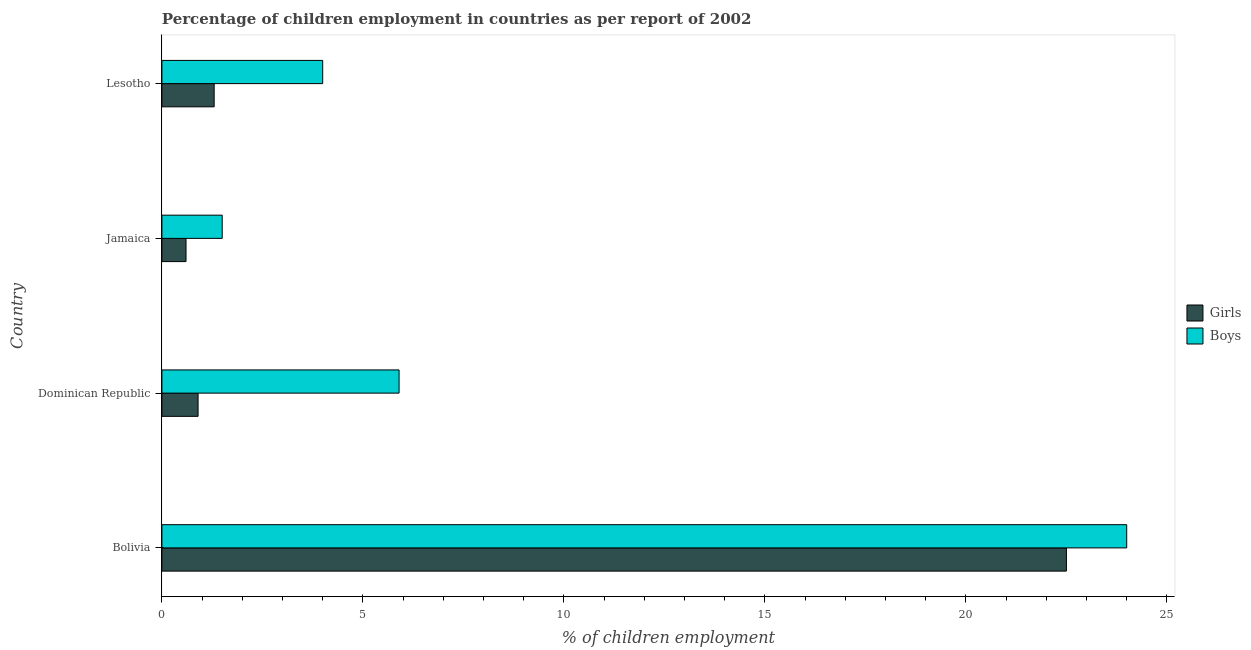How many groups of bars are there?
Your response must be concise. 4. Are the number of bars per tick equal to the number of legend labels?
Offer a very short reply. Yes. What is the label of the 2nd group of bars from the top?
Provide a succinct answer. Jamaica. In how many cases, is the number of bars for a given country not equal to the number of legend labels?
Give a very brief answer. 0. What is the percentage of employed boys in Dominican Republic?
Your response must be concise. 5.9. Across all countries, what is the minimum percentage of employed boys?
Your answer should be compact. 1.5. In which country was the percentage of employed boys minimum?
Keep it short and to the point. Jamaica. What is the total percentage of employed boys in the graph?
Give a very brief answer. 35.4. What is the difference between the percentage of employed boys in Dominican Republic and the percentage of employed girls in Bolivia?
Provide a short and direct response. -16.6. What is the average percentage of employed girls per country?
Keep it short and to the point. 6.33. In how many countries, is the percentage of employed boys greater than 22 %?
Make the answer very short. 1. What is the ratio of the percentage of employed girls in Dominican Republic to that in Lesotho?
Provide a succinct answer. 0.69. What is the difference between the highest and the second highest percentage of employed boys?
Your response must be concise. 18.1. What is the difference between the highest and the lowest percentage of employed girls?
Give a very brief answer. 21.9. What does the 1st bar from the top in Bolivia represents?
Give a very brief answer. Boys. What does the 1st bar from the bottom in Bolivia represents?
Make the answer very short. Girls. How many countries are there in the graph?
Offer a very short reply. 4. What is the difference between two consecutive major ticks on the X-axis?
Provide a short and direct response. 5. Are the values on the major ticks of X-axis written in scientific E-notation?
Make the answer very short. No. Where does the legend appear in the graph?
Your response must be concise. Center right. What is the title of the graph?
Ensure brevity in your answer.  Percentage of children employment in countries as per report of 2002. Does "External balance on goods" appear as one of the legend labels in the graph?
Your answer should be compact. No. What is the label or title of the X-axis?
Provide a succinct answer. % of children employment. What is the % of children employment of Girls in Bolivia?
Provide a short and direct response. 22.5. What is the % of children employment of Boys in Bolivia?
Offer a terse response. 24. What is the % of children employment of Boys in Lesotho?
Ensure brevity in your answer.  4. Across all countries, what is the maximum % of children employment in Girls?
Offer a terse response. 22.5. Across all countries, what is the minimum % of children employment in Boys?
Offer a terse response. 1.5. What is the total % of children employment of Girls in the graph?
Ensure brevity in your answer.  25.3. What is the total % of children employment of Boys in the graph?
Your response must be concise. 35.4. What is the difference between the % of children employment of Girls in Bolivia and that in Dominican Republic?
Provide a succinct answer. 21.6. What is the difference between the % of children employment of Girls in Bolivia and that in Jamaica?
Provide a succinct answer. 21.9. What is the difference between the % of children employment in Girls in Bolivia and that in Lesotho?
Provide a short and direct response. 21.2. What is the difference between the % of children employment of Boys in Bolivia and that in Lesotho?
Keep it short and to the point. 20. What is the difference between the % of children employment in Boys in Dominican Republic and that in Jamaica?
Make the answer very short. 4.4. What is the difference between the % of children employment of Girls in Dominican Republic and that in Lesotho?
Give a very brief answer. -0.4. What is the difference between the % of children employment of Boys in Dominican Republic and that in Lesotho?
Your answer should be compact. 1.9. What is the difference between the % of children employment of Boys in Jamaica and that in Lesotho?
Keep it short and to the point. -2.5. What is the difference between the % of children employment of Girls in Bolivia and the % of children employment of Boys in Dominican Republic?
Offer a very short reply. 16.6. What is the difference between the % of children employment in Girls in Bolivia and the % of children employment in Boys in Lesotho?
Your response must be concise. 18.5. What is the difference between the % of children employment in Girls in Dominican Republic and the % of children employment in Boys in Lesotho?
Ensure brevity in your answer.  -3.1. What is the difference between the % of children employment in Girls in Jamaica and the % of children employment in Boys in Lesotho?
Give a very brief answer. -3.4. What is the average % of children employment in Girls per country?
Provide a short and direct response. 6.33. What is the average % of children employment of Boys per country?
Provide a succinct answer. 8.85. What is the difference between the % of children employment of Girls and % of children employment of Boys in Dominican Republic?
Provide a short and direct response. -5. What is the difference between the % of children employment of Girls and % of children employment of Boys in Lesotho?
Your response must be concise. -2.7. What is the ratio of the % of children employment of Boys in Bolivia to that in Dominican Republic?
Offer a terse response. 4.07. What is the ratio of the % of children employment in Girls in Bolivia to that in Jamaica?
Provide a short and direct response. 37.5. What is the ratio of the % of children employment in Boys in Bolivia to that in Jamaica?
Offer a very short reply. 16. What is the ratio of the % of children employment in Girls in Bolivia to that in Lesotho?
Ensure brevity in your answer.  17.31. What is the ratio of the % of children employment in Boys in Bolivia to that in Lesotho?
Your answer should be compact. 6. What is the ratio of the % of children employment in Girls in Dominican Republic to that in Jamaica?
Your response must be concise. 1.5. What is the ratio of the % of children employment of Boys in Dominican Republic to that in Jamaica?
Give a very brief answer. 3.93. What is the ratio of the % of children employment in Girls in Dominican Republic to that in Lesotho?
Your response must be concise. 0.69. What is the ratio of the % of children employment in Boys in Dominican Republic to that in Lesotho?
Offer a terse response. 1.48. What is the ratio of the % of children employment of Girls in Jamaica to that in Lesotho?
Ensure brevity in your answer.  0.46. What is the difference between the highest and the second highest % of children employment of Girls?
Your answer should be compact. 21.2. What is the difference between the highest and the second highest % of children employment in Boys?
Ensure brevity in your answer.  18.1. What is the difference between the highest and the lowest % of children employment in Girls?
Provide a succinct answer. 21.9. What is the difference between the highest and the lowest % of children employment in Boys?
Your response must be concise. 22.5. 